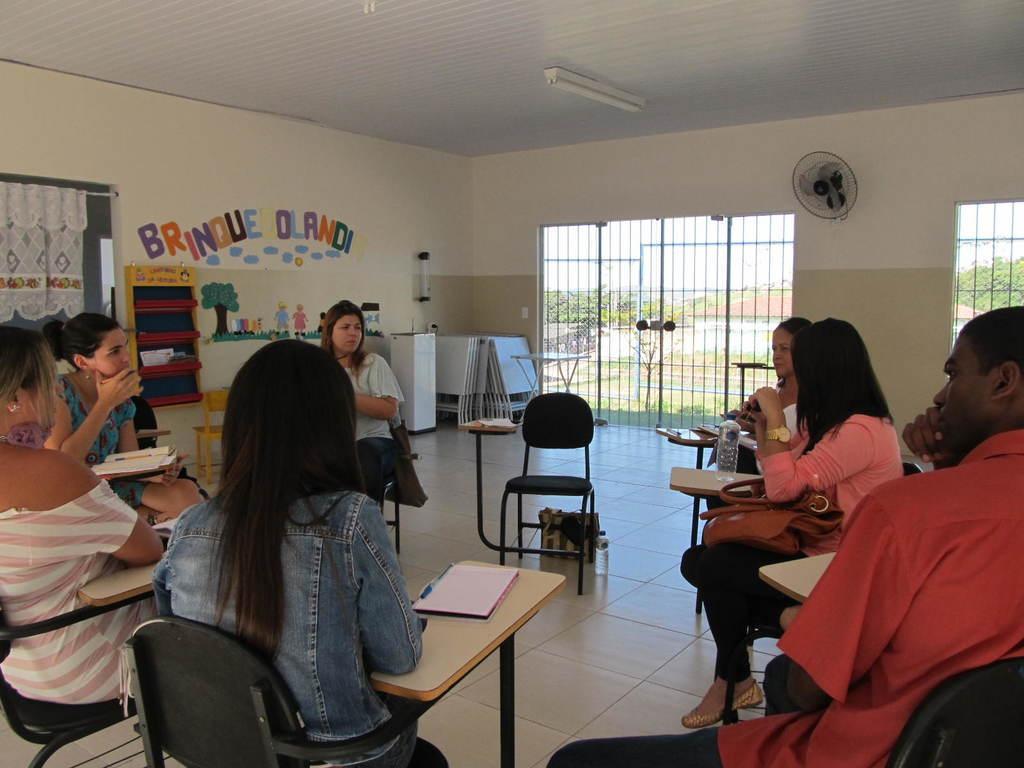Can you describe this image briefly? This image is taken in a room. In this room there are seven people, six woman and one men. At the left side of the image there are four women sitting on a chair. In the right side of the image there are two women and one man sitting on a chairs. There is a floor and a railing in this room and a table fan. At the top most of the image there is a ceiling with a tube light. In middle of the wall there is a text written with a paint. In the left side of the image there is a window with a curtain. 